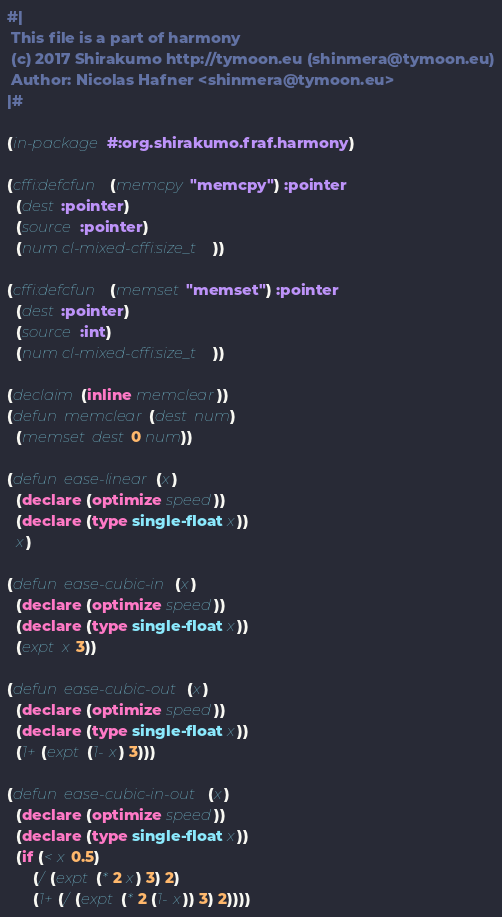<code> <loc_0><loc_0><loc_500><loc_500><_Lisp_>#|
 This file is a part of harmony
 (c) 2017 Shirakumo http://tymoon.eu (shinmera@tymoon.eu)
 Author: Nicolas Hafner <shinmera@tymoon.eu>
|#

(in-package #:org.shirakumo.fraf.harmony)

(cffi:defcfun (memcpy "memcpy") :pointer
  (dest :pointer)
  (source :pointer)
  (num cl-mixed-cffi:size_t))

(cffi:defcfun (memset "memset") :pointer
  (dest :pointer)
  (source :int)
  (num cl-mixed-cffi:size_t))

(declaim (inline memclear))
(defun memclear (dest num)
  (memset dest 0 num))

(defun ease-linear (x)
  (declare (optimize speed))
  (declare (type single-float x))
  x)

(defun ease-cubic-in (x)
  (declare (optimize speed))
  (declare (type single-float x))
  (expt x 3))

(defun ease-cubic-out (x)
  (declare (optimize speed))
  (declare (type single-float x))
  (1+ (expt (1- x) 3)))

(defun ease-cubic-in-out (x)
  (declare (optimize speed))
  (declare (type single-float x))
  (if (< x 0.5)
      (/ (expt (* 2 x) 3) 2)
      (1+ (/ (expt (* 2 (1- x)) 3) 2))))
</code> 